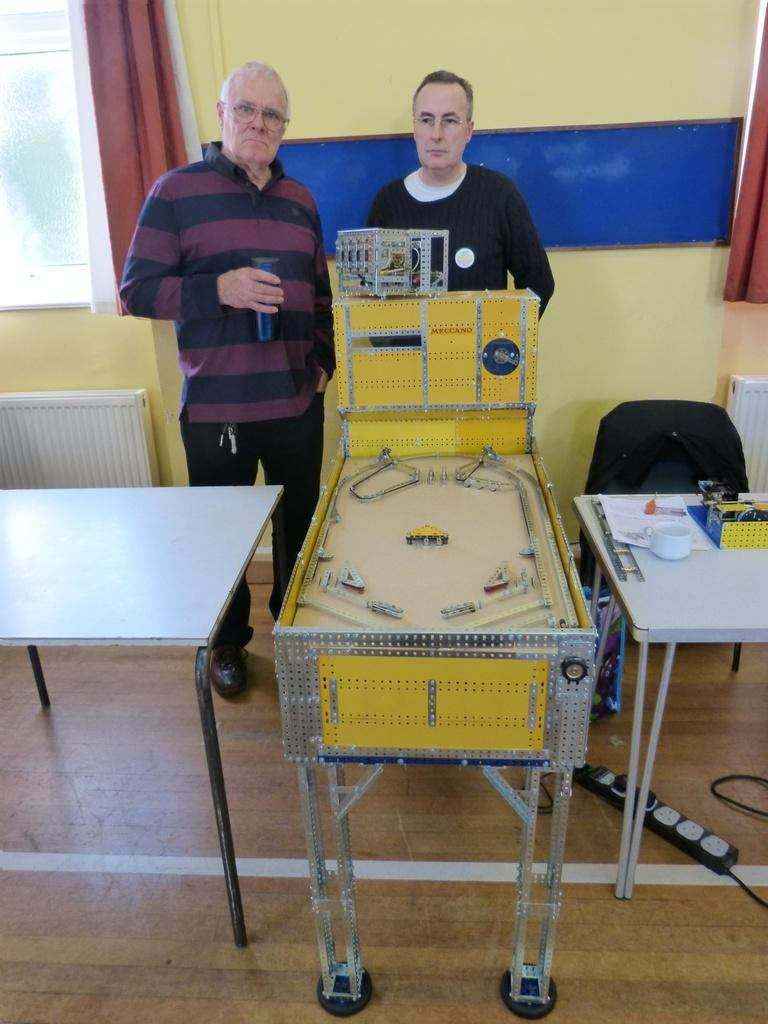How many people are in the image? There are two men standing in the image. What can be seen in the background of the image? Curtains are visible in the image. What objects are present in the image? There are tables in the image. What is one of the men holding? One of the men is holding a bottle. What accessory is one of the men wearing? One of the men is wearing glasses (specs). What type of carriage can be seen in the image? There is no carriage present in the image. What selection of prose is being discussed by the men in the image? There is no indication of a discussion about prose in the image. 